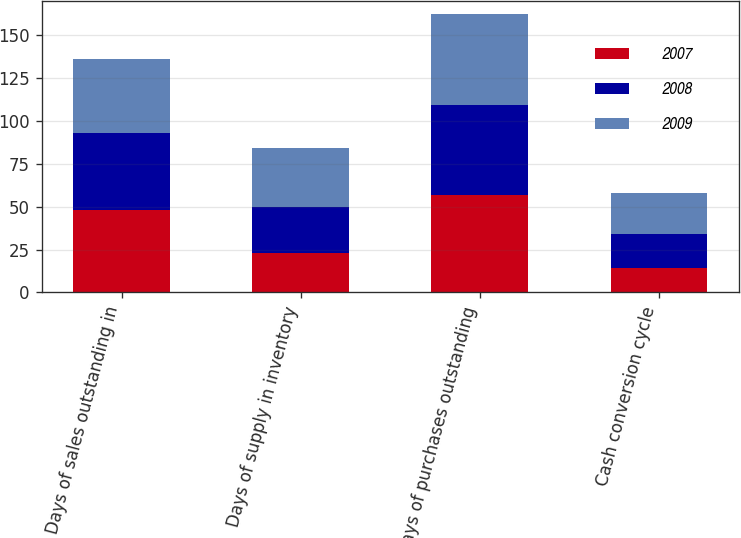Convert chart to OTSL. <chart><loc_0><loc_0><loc_500><loc_500><stacked_bar_chart><ecel><fcel>Days of sales outstanding in<fcel>Days of supply in inventory<fcel>Days of purchases outstanding<fcel>Cash conversion cycle<nl><fcel>2007<fcel>48<fcel>23<fcel>57<fcel>14<nl><fcel>2008<fcel>45<fcel>27<fcel>52<fcel>20<nl><fcel>2009<fcel>43<fcel>34<fcel>53<fcel>24<nl></chart> 